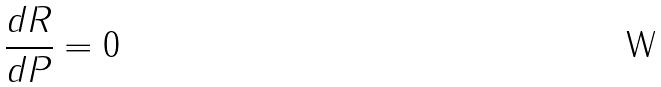<formula> <loc_0><loc_0><loc_500><loc_500>\frac { d R } { d P } = 0</formula> 